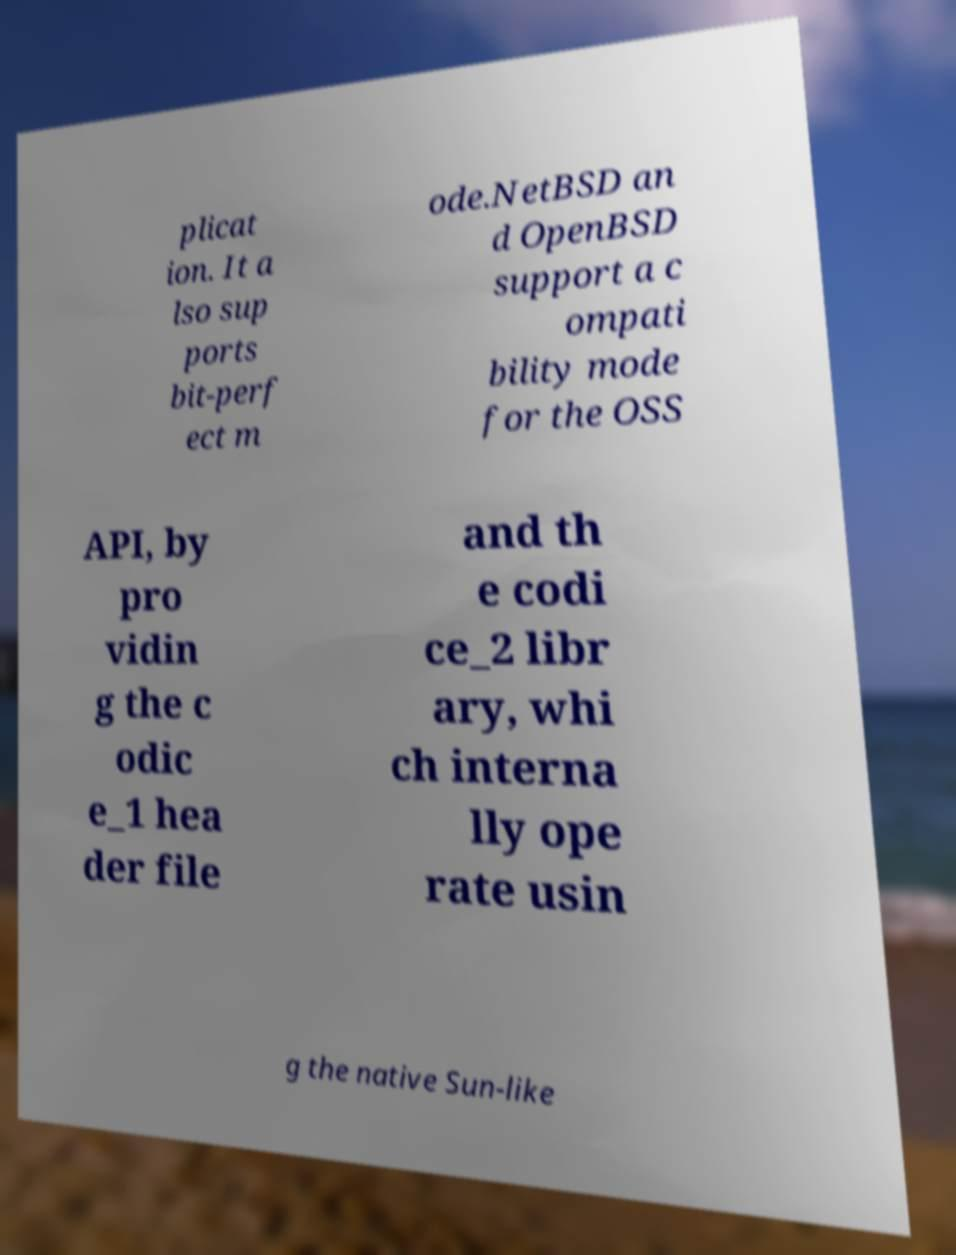Can you accurately transcribe the text from the provided image for me? plicat ion. It a lso sup ports bit-perf ect m ode.NetBSD an d OpenBSD support a c ompati bility mode for the OSS API, by pro vidin g the c odic e_1 hea der file and th e codi ce_2 libr ary, whi ch interna lly ope rate usin g the native Sun-like 